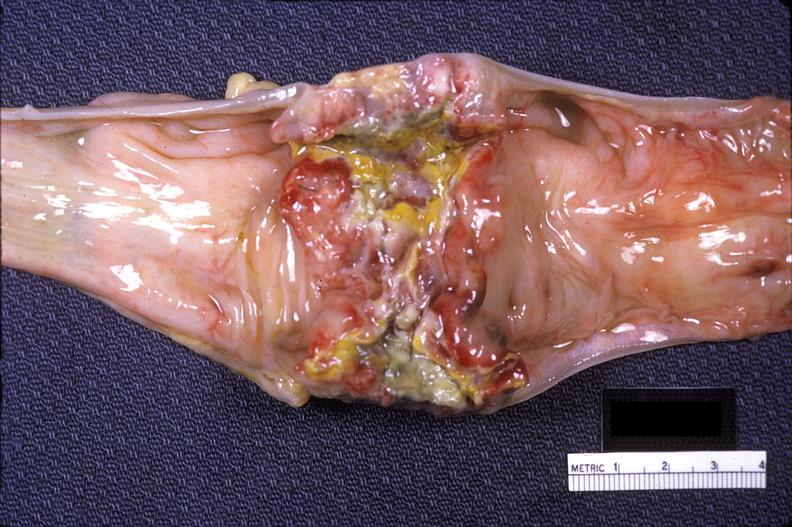does this image show colon sigmoid, adenocarcinoma, annular?
Answer the question using a single word or phrase. Yes 